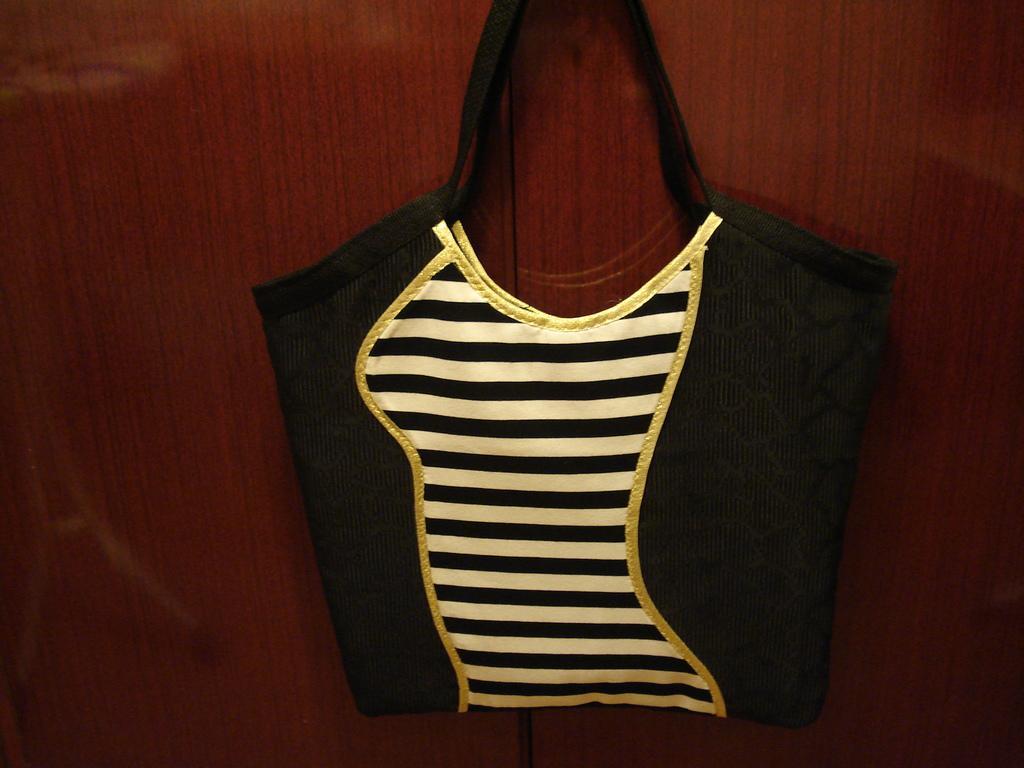Please provide a concise description of this image. In this picture we can see a bag hanged to the wall and on bag we can see black and white lines with some design. 